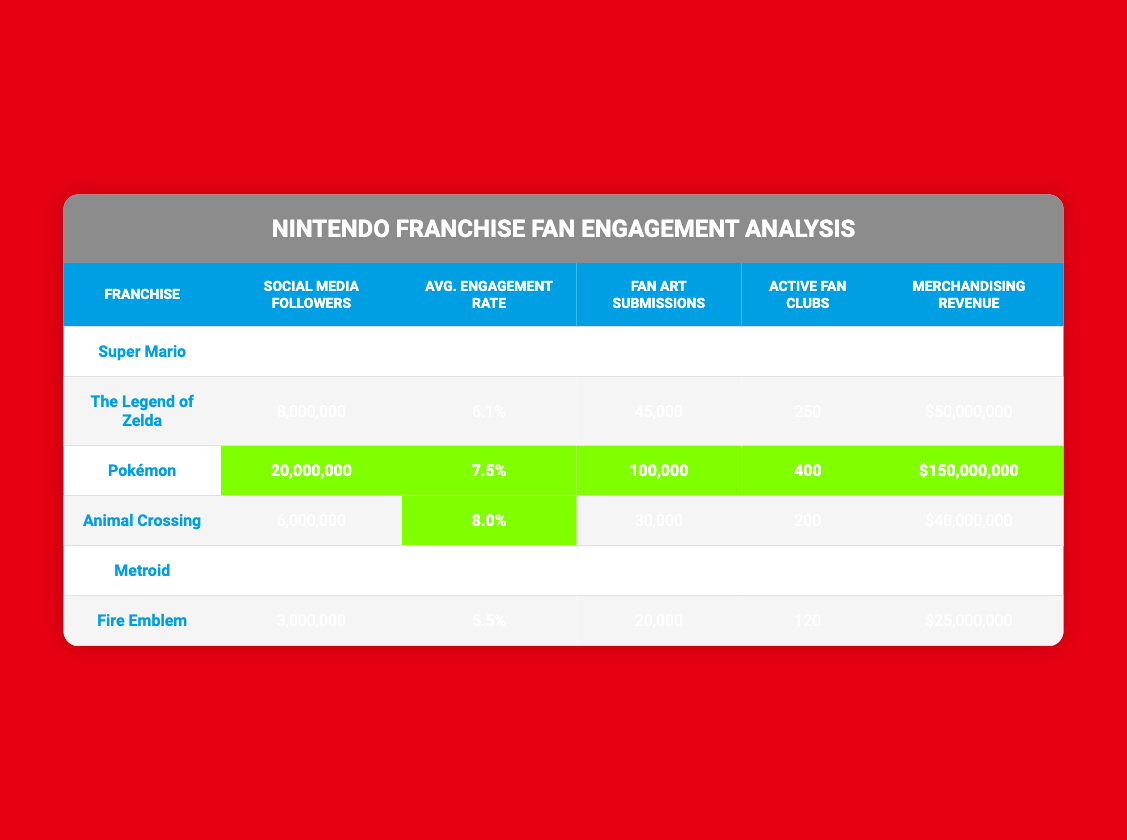What is the franchise with the highest number of social media followers? Pokémon has the highest number of social media followers at 20,000,000. This can be determined by checking the "Social Media Followers" column and identifying the largest value.
Answer: Pokémon Which franchise has the highest average engagement rate? Animal Crossing has the highest average engagement rate at 8.0%. This is found by looking at the "Avg. Engagement Rate" column and locating the maximum value.
Answer: Animal Crossing How many fan art submissions does Super Mario have? Super Mario has 50,000 fan art submissions, as indicated in the "Fan Art Submissions" column for the Super Mario row.
Answer: 50,000 What is the total merchandising revenue for The Legend of Zelda and Fire Emblem combined? The merchandising revenue for The Legend of Zelda is $50,000,000, and for Fire Emblem, it is $25,000,000. Adding these two values gives $50,000,000 + $25,000,000 = $75,000,000.
Answer: $75,000,000 Does Animal Crossing have more active fan clubs than Metroid? Yes, Animal Crossing has 200 active fan clubs, whereas Metroid has 100 active fan clubs. Comparing these values in the "Active Fan Clubs" column confirms this.
Answer: Yes What is the difference in fan art submissions between Pokémon and Metroid? Pokémon has 100,000 fan art submissions and Metroid has 15,000. The difference is calculated by subtracting: 100,000 - 15,000 = 85,000.
Answer: 85,000 Which franchise has the least merchandising revenue? Metroid has the least merchandising revenue at $15,000,000. This is determined by comparing the values in the "Merchandising Revenue" column and identifying the smallest amount.
Answer: Metroid If we combine the social media followers of Super Mario, The Legend of Zelda, and Fire Emblem, what is the total? The total social media followers for Super Mario (10,000,000), The Legend of Zelda (8,000,000), and Fire Emblem (3,000,000) is calculated as: 10,000,000 + 8,000,000 + 3,000,000 = 21,000,000.
Answer: 21,000,000 Is the average engagement rate of Fire Emblem higher than that of Super Mario? No, Fire Emblem has an average engagement rate of 5.5% while Super Mario has 5.2%. Comparing the "Avg. Engagement Rate" values shows that Fire Emblem's rate is actually higher.
Answer: Yes What percentage increase in social media followers does Pokémon have compared to Animal Crossing? Pokémon has 20,000,000 followers and Animal Crossing has 6,000,000. To find the percentage increase: ((20,000,000 - 6,000,000) / 6,000,000) * 100 = 233.33%.
Answer: 233.33% 